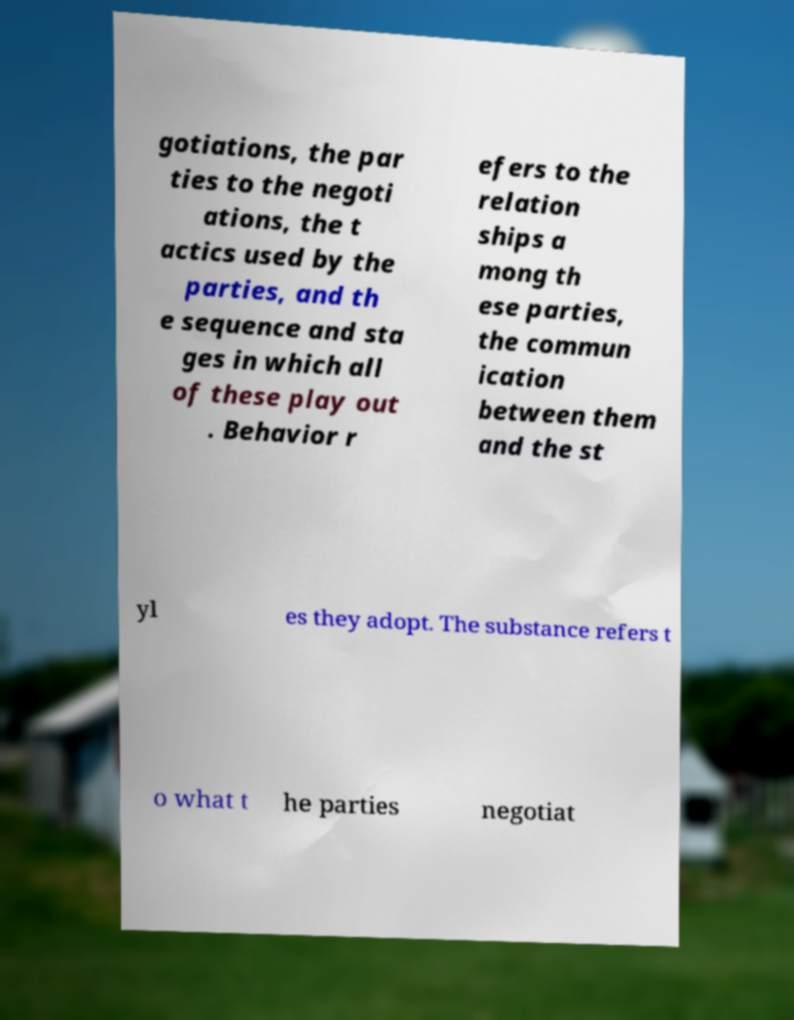Please read and relay the text visible in this image. What does it say? gotiations, the par ties to the negoti ations, the t actics used by the parties, and th e sequence and sta ges in which all of these play out . Behavior r efers to the relation ships a mong th ese parties, the commun ication between them and the st yl es they adopt. The substance refers t o what t he parties negotiat 